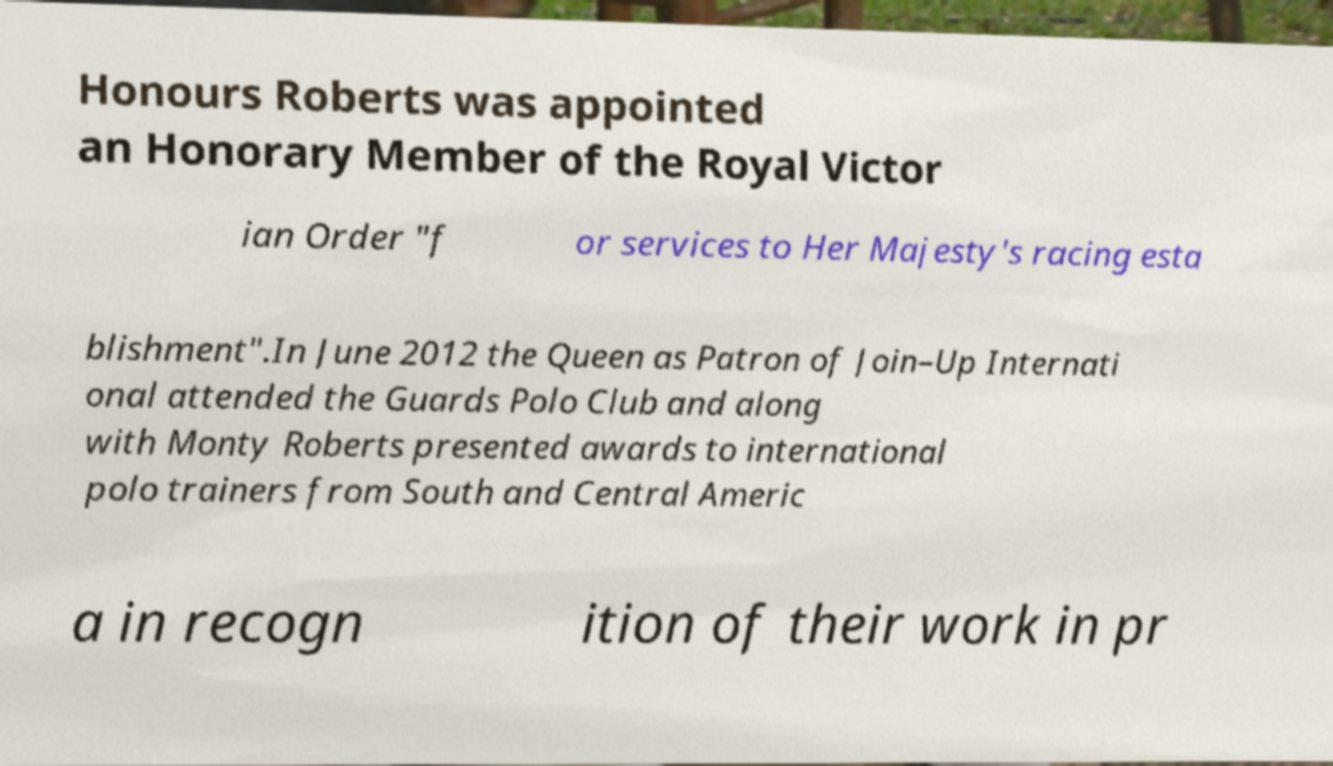Can you accurately transcribe the text from the provided image for me? Honours Roberts was appointed an Honorary Member of the Royal Victor ian Order "f or services to Her Majesty's racing esta blishment".In June 2012 the Queen as Patron of Join–Up Internati onal attended the Guards Polo Club and along with Monty Roberts presented awards to international polo trainers from South and Central Americ a in recogn ition of their work in pr 